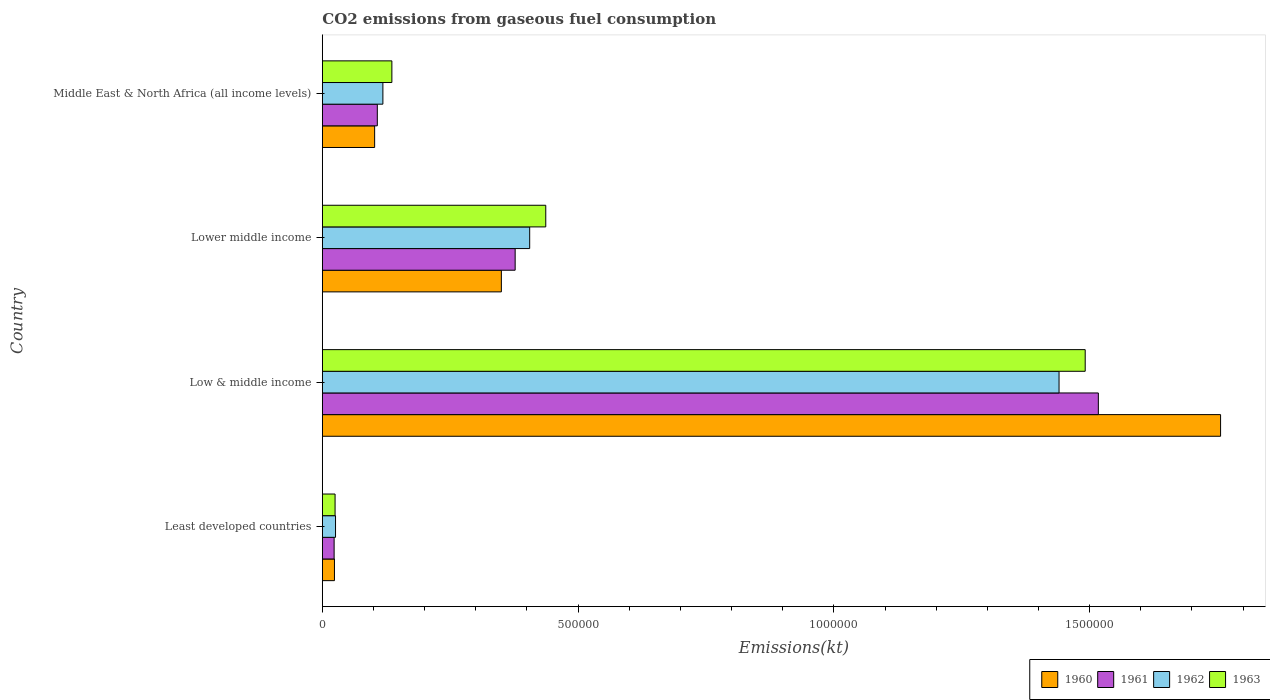How many different coloured bars are there?
Your answer should be compact. 4. How many groups of bars are there?
Your answer should be compact. 4. Are the number of bars per tick equal to the number of legend labels?
Offer a terse response. Yes. What is the label of the 4th group of bars from the top?
Keep it short and to the point. Least developed countries. What is the amount of CO2 emitted in 1961 in Lower middle income?
Ensure brevity in your answer.  3.77e+05. Across all countries, what is the maximum amount of CO2 emitted in 1960?
Keep it short and to the point. 1.76e+06. Across all countries, what is the minimum amount of CO2 emitted in 1962?
Ensure brevity in your answer.  2.58e+04. In which country was the amount of CO2 emitted in 1961 minimum?
Offer a very short reply. Least developed countries. What is the total amount of CO2 emitted in 1963 in the graph?
Your answer should be very brief. 2.09e+06. What is the difference between the amount of CO2 emitted in 1960 in Least developed countries and that in Low & middle income?
Ensure brevity in your answer.  -1.73e+06. What is the difference between the amount of CO2 emitted in 1963 in Lower middle income and the amount of CO2 emitted in 1962 in Middle East & North Africa (all income levels)?
Provide a short and direct response. 3.18e+05. What is the average amount of CO2 emitted in 1961 per country?
Make the answer very short. 5.06e+05. What is the difference between the amount of CO2 emitted in 1960 and amount of CO2 emitted in 1961 in Lower middle income?
Your answer should be very brief. -2.70e+04. In how many countries, is the amount of CO2 emitted in 1963 greater than 400000 kt?
Provide a succinct answer. 2. What is the ratio of the amount of CO2 emitted in 1960 in Least developed countries to that in Low & middle income?
Your answer should be compact. 0.01. Is the amount of CO2 emitted in 1960 in Low & middle income less than that in Lower middle income?
Your answer should be compact. No. What is the difference between the highest and the second highest amount of CO2 emitted in 1960?
Make the answer very short. 1.41e+06. What is the difference between the highest and the lowest amount of CO2 emitted in 1962?
Give a very brief answer. 1.41e+06. How many countries are there in the graph?
Your answer should be compact. 4. Are the values on the major ticks of X-axis written in scientific E-notation?
Your answer should be very brief. No. Does the graph contain any zero values?
Make the answer very short. No. Does the graph contain grids?
Offer a very short reply. No. Where does the legend appear in the graph?
Make the answer very short. Bottom right. How are the legend labels stacked?
Your answer should be very brief. Horizontal. What is the title of the graph?
Ensure brevity in your answer.  CO2 emissions from gaseous fuel consumption. Does "1997" appear as one of the legend labels in the graph?
Ensure brevity in your answer.  No. What is the label or title of the X-axis?
Provide a short and direct response. Emissions(kt). What is the Emissions(kt) of 1960 in Least developed countries?
Ensure brevity in your answer.  2.37e+04. What is the Emissions(kt) of 1961 in Least developed countries?
Give a very brief answer. 2.31e+04. What is the Emissions(kt) of 1962 in Least developed countries?
Provide a short and direct response. 2.58e+04. What is the Emissions(kt) in 1963 in Least developed countries?
Keep it short and to the point. 2.49e+04. What is the Emissions(kt) of 1960 in Low & middle income?
Offer a very short reply. 1.76e+06. What is the Emissions(kt) in 1961 in Low & middle income?
Ensure brevity in your answer.  1.52e+06. What is the Emissions(kt) of 1962 in Low & middle income?
Your answer should be compact. 1.44e+06. What is the Emissions(kt) in 1963 in Low & middle income?
Keep it short and to the point. 1.49e+06. What is the Emissions(kt) in 1960 in Lower middle income?
Your response must be concise. 3.50e+05. What is the Emissions(kt) in 1961 in Lower middle income?
Ensure brevity in your answer.  3.77e+05. What is the Emissions(kt) in 1962 in Lower middle income?
Keep it short and to the point. 4.05e+05. What is the Emissions(kt) in 1963 in Lower middle income?
Provide a succinct answer. 4.37e+05. What is the Emissions(kt) in 1960 in Middle East & North Africa (all income levels)?
Your answer should be compact. 1.02e+05. What is the Emissions(kt) of 1961 in Middle East & North Africa (all income levels)?
Ensure brevity in your answer.  1.07e+05. What is the Emissions(kt) in 1962 in Middle East & North Africa (all income levels)?
Offer a very short reply. 1.18e+05. What is the Emissions(kt) of 1963 in Middle East & North Africa (all income levels)?
Offer a terse response. 1.36e+05. Across all countries, what is the maximum Emissions(kt) of 1960?
Your answer should be compact. 1.76e+06. Across all countries, what is the maximum Emissions(kt) in 1961?
Your answer should be compact. 1.52e+06. Across all countries, what is the maximum Emissions(kt) in 1962?
Your answer should be compact. 1.44e+06. Across all countries, what is the maximum Emissions(kt) of 1963?
Give a very brief answer. 1.49e+06. Across all countries, what is the minimum Emissions(kt) in 1960?
Your response must be concise. 2.37e+04. Across all countries, what is the minimum Emissions(kt) of 1961?
Give a very brief answer. 2.31e+04. Across all countries, what is the minimum Emissions(kt) of 1962?
Your answer should be very brief. 2.58e+04. Across all countries, what is the minimum Emissions(kt) of 1963?
Make the answer very short. 2.49e+04. What is the total Emissions(kt) of 1960 in the graph?
Provide a succinct answer. 2.23e+06. What is the total Emissions(kt) of 1961 in the graph?
Provide a short and direct response. 2.02e+06. What is the total Emissions(kt) of 1962 in the graph?
Make the answer very short. 1.99e+06. What is the total Emissions(kt) in 1963 in the graph?
Provide a short and direct response. 2.09e+06. What is the difference between the Emissions(kt) of 1960 in Least developed countries and that in Low & middle income?
Your answer should be compact. -1.73e+06. What is the difference between the Emissions(kt) in 1961 in Least developed countries and that in Low & middle income?
Provide a short and direct response. -1.49e+06. What is the difference between the Emissions(kt) in 1962 in Least developed countries and that in Low & middle income?
Give a very brief answer. -1.41e+06. What is the difference between the Emissions(kt) in 1963 in Least developed countries and that in Low & middle income?
Keep it short and to the point. -1.47e+06. What is the difference between the Emissions(kt) of 1960 in Least developed countries and that in Lower middle income?
Offer a very short reply. -3.26e+05. What is the difference between the Emissions(kt) of 1961 in Least developed countries and that in Lower middle income?
Ensure brevity in your answer.  -3.54e+05. What is the difference between the Emissions(kt) in 1962 in Least developed countries and that in Lower middle income?
Offer a terse response. -3.80e+05. What is the difference between the Emissions(kt) in 1963 in Least developed countries and that in Lower middle income?
Offer a terse response. -4.12e+05. What is the difference between the Emissions(kt) of 1960 in Least developed countries and that in Middle East & North Africa (all income levels)?
Offer a terse response. -7.86e+04. What is the difference between the Emissions(kt) in 1961 in Least developed countries and that in Middle East & North Africa (all income levels)?
Your answer should be compact. -8.44e+04. What is the difference between the Emissions(kt) of 1962 in Least developed countries and that in Middle East & North Africa (all income levels)?
Offer a terse response. -9.26e+04. What is the difference between the Emissions(kt) in 1963 in Least developed countries and that in Middle East & North Africa (all income levels)?
Your answer should be compact. -1.11e+05. What is the difference between the Emissions(kt) in 1960 in Low & middle income and that in Lower middle income?
Your answer should be very brief. 1.41e+06. What is the difference between the Emissions(kt) in 1961 in Low & middle income and that in Lower middle income?
Offer a terse response. 1.14e+06. What is the difference between the Emissions(kt) of 1962 in Low & middle income and that in Lower middle income?
Your response must be concise. 1.03e+06. What is the difference between the Emissions(kt) of 1963 in Low & middle income and that in Lower middle income?
Your response must be concise. 1.05e+06. What is the difference between the Emissions(kt) of 1960 in Low & middle income and that in Middle East & North Africa (all income levels)?
Keep it short and to the point. 1.65e+06. What is the difference between the Emissions(kt) of 1961 in Low & middle income and that in Middle East & North Africa (all income levels)?
Offer a terse response. 1.41e+06. What is the difference between the Emissions(kt) of 1962 in Low & middle income and that in Middle East & North Africa (all income levels)?
Give a very brief answer. 1.32e+06. What is the difference between the Emissions(kt) in 1963 in Low & middle income and that in Middle East & North Africa (all income levels)?
Provide a short and direct response. 1.36e+06. What is the difference between the Emissions(kt) in 1960 in Lower middle income and that in Middle East & North Africa (all income levels)?
Offer a terse response. 2.48e+05. What is the difference between the Emissions(kt) of 1961 in Lower middle income and that in Middle East & North Africa (all income levels)?
Your response must be concise. 2.69e+05. What is the difference between the Emissions(kt) of 1962 in Lower middle income and that in Middle East & North Africa (all income levels)?
Ensure brevity in your answer.  2.87e+05. What is the difference between the Emissions(kt) in 1963 in Lower middle income and that in Middle East & North Africa (all income levels)?
Give a very brief answer. 3.01e+05. What is the difference between the Emissions(kt) in 1960 in Least developed countries and the Emissions(kt) in 1961 in Low & middle income?
Your answer should be compact. -1.49e+06. What is the difference between the Emissions(kt) in 1960 in Least developed countries and the Emissions(kt) in 1962 in Low & middle income?
Offer a very short reply. -1.42e+06. What is the difference between the Emissions(kt) of 1960 in Least developed countries and the Emissions(kt) of 1963 in Low & middle income?
Keep it short and to the point. -1.47e+06. What is the difference between the Emissions(kt) of 1961 in Least developed countries and the Emissions(kt) of 1962 in Low & middle income?
Offer a very short reply. -1.42e+06. What is the difference between the Emissions(kt) of 1961 in Least developed countries and the Emissions(kt) of 1963 in Low & middle income?
Make the answer very short. -1.47e+06. What is the difference between the Emissions(kt) of 1962 in Least developed countries and the Emissions(kt) of 1963 in Low & middle income?
Offer a very short reply. -1.47e+06. What is the difference between the Emissions(kt) of 1960 in Least developed countries and the Emissions(kt) of 1961 in Lower middle income?
Your answer should be very brief. -3.53e+05. What is the difference between the Emissions(kt) of 1960 in Least developed countries and the Emissions(kt) of 1962 in Lower middle income?
Your answer should be very brief. -3.82e+05. What is the difference between the Emissions(kt) in 1960 in Least developed countries and the Emissions(kt) in 1963 in Lower middle income?
Make the answer very short. -4.13e+05. What is the difference between the Emissions(kt) of 1961 in Least developed countries and the Emissions(kt) of 1962 in Lower middle income?
Your answer should be compact. -3.82e+05. What is the difference between the Emissions(kt) of 1961 in Least developed countries and the Emissions(kt) of 1963 in Lower middle income?
Keep it short and to the point. -4.14e+05. What is the difference between the Emissions(kt) in 1962 in Least developed countries and the Emissions(kt) in 1963 in Lower middle income?
Your answer should be very brief. -4.11e+05. What is the difference between the Emissions(kt) in 1960 in Least developed countries and the Emissions(kt) in 1961 in Middle East & North Africa (all income levels)?
Provide a succinct answer. -8.38e+04. What is the difference between the Emissions(kt) in 1960 in Least developed countries and the Emissions(kt) in 1962 in Middle East & North Africa (all income levels)?
Ensure brevity in your answer.  -9.47e+04. What is the difference between the Emissions(kt) of 1960 in Least developed countries and the Emissions(kt) of 1963 in Middle East & North Africa (all income levels)?
Make the answer very short. -1.12e+05. What is the difference between the Emissions(kt) of 1961 in Least developed countries and the Emissions(kt) of 1962 in Middle East & North Africa (all income levels)?
Offer a terse response. -9.53e+04. What is the difference between the Emissions(kt) in 1961 in Least developed countries and the Emissions(kt) in 1963 in Middle East & North Africa (all income levels)?
Keep it short and to the point. -1.13e+05. What is the difference between the Emissions(kt) of 1962 in Least developed countries and the Emissions(kt) of 1963 in Middle East & North Africa (all income levels)?
Your answer should be compact. -1.10e+05. What is the difference between the Emissions(kt) of 1960 in Low & middle income and the Emissions(kt) of 1961 in Lower middle income?
Provide a succinct answer. 1.38e+06. What is the difference between the Emissions(kt) of 1960 in Low & middle income and the Emissions(kt) of 1962 in Lower middle income?
Provide a succinct answer. 1.35e+06. What is the difference between the Emissions(kt) of 1960 in Low & middle income and the Emissions(kt) of 1963 in Lower middle income?
Offer a very short reply. 1.32e+06. What is the difference between the Emissions(kt) in 1961 in Low & middle income and the Emissions(kt) in 1962 in Lower middle income?
Provide a succinct answer. 1.11e+06. What is the difference between the Emissions(kt) in 1961 in Low & middle income and the Emissions(kt) in 1963 in Lower middle income?
Give a very brief answer. 1.08e+06. What is the difference between the Emissions(kt) of 1962 in Low & middle income and the Emissions(kt) of 1963 in Lower middle income?
Offer a terse response. 1.00e+06. What is the difference between the Emissions(kt) of 1960 in Low & middle income and the Emissions(kt) of 1961 in Middle East & North Africa (all income levels)?
Ensure brevity in your answer.  1.65e+06. What is the difference between the Emissions(kt) of 1960 in Low & middle income and the Emissions(kt) of 1962 in Middle East & North Africa (all income levels)?
Provide a short and direct response. 1.64e+06. What is the difference between the Emissions(kt) of 1960 in Low & middle income and the Emissions(kt) of 1963 in Middle East & North Africa (all income levels)?
Your response must be concise. 1.62e+06. What is the difference between the Emissions(kt) in 1961 in Low & middle income and the Emissions(kt) in 1962 in Middle East & North Africa (all income levels)?
Your response must be concise. 1.40e+06. What is the difference between the Emissions(kt) in 1961 in Low & middle income and the Emissions(kt) in 1963 in Middle East & North Africa (all income levels)?
Provide a succinct answer. 1.38e+06. What is the difference between the Emissions(kt) of 1962 in Low & middle income and the Emissions(kt) of 1963 in Middle East & North Africa (all income levels)?
Offer a very short reply. 1.30e+06. What is the difference between the Emissions(kt) of 1960 in Lower middle income and the Emissions(kt) of 1961 in Middle East & North Africa (all income levels)?
Keep it short and to the point. 2.42e+05. What is the difference between the Emissions(kt) in 1960 in Lower middle income and the Emissions(kt) in 1962 in Middle East & North Africa (all income levels)?
Offer a terse response. 2.32e+05. What is the difference between the Emissions(kt) in 1960 in Lower middle income and the Emissions(kt) in 1963 in Middle East & North Africa (all income levels)?
Provide a succinct answer. 2.14e+05. What is the difference between the Emissions(kt) of 1961 in Lower middle income and the Emissions(kt) of 1962 in Middle East & North Africa (all income levels)?
Offer a very short reply. 2.59e+05. What is the difference between the Emissions(kt) in 1961 in Lower middle income and the Emissions(kt) in 1963 in Middle East & North Africa (all income levels)?
Ensure brevity in your answer.  2.41e+05. What is the difference between the Emissions(kt) of 1962 in Lower middle income and the Emissions(kt) of 1963 in Middle East & North Africa (all income levels)?
Give a very brief answer. 2.69e+05. What is the average Emissions(kt) of 1960 per country?
Provide a succinct answer. 5.58e+05. What is the average Emissions(kt) in 1961 per country?
Keep it short and to the point. 5.06e+05. What is the average Emissions(kt) in 1962 per country?
Keep it short and to the point. 4.97e+05. What is the average Emissions(kt) of 1963 per country?
Your answer should be very brief. 5.22e+05. What is the difference between the Emissions(kt) of 1960 and Emissions(kt) of 1961 in Least developed countries?
Keep it short and to the point. 649.13. What is the difference between the Emissions(kt) in 1960 and Emissions(kt) in 1962 in Least developed countries?
Offer a very short reply. -2100.39. What is the difference between the Emissions(kt) of 1960 and Emissions(kt) of 1963 in Least developed countries?
Your answer should be very brief. -1221.77. What is the difference between the Emissions(kt) of 1961 and Emissions(kt) of 1962 in Least developed countries?
Your answer should be compact. -2749.52. What is the difference between the Emissions(kt) of 1961 and Emissions(kt) of 1963 in Least developed countries?
Offer a terse response. -1870.9. What is the difference between the Emissions(kt) of 1962 and Emissions(kt) of 1963 in Least developed countries?
Provide a short and direct response. 878.62. What is the difference between the Emissions(kt) of 1960 and Emissions(kt) of 1961 in Low & middle income?
Keep it short and to the point. 2.39e+05. What is the difference between the Emissions(kt) in 1960 and Emissions(kt) in 1962 in Low & middle income?
Give a very brief answer. 3.16e+05. What is the difference between the Emissions(kt) in 1960 and Emissions(kt) in 1963 in Low & middle income?
Make the answer very short. 2.65e+05. What is the difference between the Emissions(kt) of 1961 and Emissions(kt) of 1962 in Low & middle income?
Make the answer very short. 7.68e+04. What is the difference between the Emissions(kt) in 1961 and Emissions(kt) in 1963 in Low & middle income?
Your answer should be very brief. 2.57e+04. What is the difference between the Emissions(kt) of 1962 and Emissions(kt) of 1963 in Low & middle income?
Offer a very short reply. -5.11e+04. What is the difference between the Emissions(kt) of 1960 and Emissions(kt) of 1961 in Lower middle income?
Your response must be concise. -2.70e+04. What is the difference between the Emissions(kt) in 1960 and Emissions(kt) in 1962 in Lower middle income?
Offer a terse response. -5.54e+04. What is the difference between the Emissions(kt) in 1960 and Emissions(kt) in 1963 in Lower middle income?
Your answer should be compact. -8.68e+04. What is the difference between the Emissions(kt) of 1961 and Emissions(kt) of 1962 in Lower middle income?
Your answer should be very brief. -2.84e+04. What is the difference between the Emissions(kt) in 1961 and Emissions(kt) in 1963 in Lower middle income?
Provide a succinct answer. -5.98e+04. What is the difference between the Emissions(kt) of 1962 and Emissions(kt) of 1963 in Lower middle income?
Offer a very short reply. -3.14e+04. What is the difference between the Emissions(kt) in 1960 and Emissions(kt) in 1961 in Middle East & North Africa (all income levels)?
Your response must be concise. -5245.97. What is the difference between the Emissions(kt) in 1960 and Emissions(kt) in 1962 in Middle East & North Africa (all income levels)?
Provide a short and direct response. -1.61e+04. What is the difference between the Emissions(kt) in 1960 and Emissions(kt) in 1963 in Middle East & North Africa (all income levels)?
Provide a short and direct response. -3.37e+04. What is the difference between the Emissions(kt) of 1961 and Emissions(kt) of 1962 in Middle East & North Africa (all income levels)?
Keep it short and to the point. -1.09e+04. What is the difference between the Emissions(kt) of 1961 and Emissions(kt) of 1963 in Middle East & North Africa (all income levels)?
Keep it short and to the point. -2.84e+04. What is the difference between the Emissions(kt) in 1962 and Emissions(kt) in 1963 in Middle East & North Africa (all income levels)?
Your answer should be very brief. -1.75e+04. What is the ratio of the Emissions(kt) of 1960 in Least developed countries to that in Low & middle income?
Give a very brief answer. 0.01. What is the ratio of the Emissions(kt) in 1961 in Least developed countries to that in Low & middle income?
Provide a short and direct response. 0.02. What is the ratio of the Emissions(kt) of 1962 in Least developed countries to that in Low & middle income?
Offer a terse response. 0.02. What is the ratio of the Emissions(kt) of 1963 in Least developed countries to that in Low & middle income?
Provide a short and direct response. 0.02. What is the ratio of the Emissions(kt) of 1960 in Least developed countries to that in Lower middle income?
Make the answer very short. 0.07. What is the ratio of the Emissions(kt) in 1961 in Least developed countries to that in Lower middle income?
Your response must be concise. 0.06. What is the ratio of the Emissions(kt) in 1962 in Least developed countries to that in Lower middle income?
Ensure brevity in your answer.  0.06. What is the ratio of the Emissions(kt) of 1963 in Least developed countries to that in Lower middle income?
Provide a succinct answer. 0.06. What is the ratio of the Emissions(kt) in 1960 in Least developed countries to that in Middle East & North Africa (all income levels)?
Offer a very short reply. 0.23. What is the ratio of the Emissions(kt) in 1961 in Least developed countries to that in Middle East & North Africa (all income levels)?
Offer a terse response. 0.21. What is the ratio of the Emissions(kt) in 1962 in Least developed countries to that in Middle East & North Africa (all income levels)?
Provide a succinct answer. 0.22. What is the ratio of the Emissions(kt) of 1963 in Least developed countries to that in Middle East & North Africa (all income levels)?
Provide a short and direct response. 0.18. What is the ratio of the Emissions(kt) of 1960 in Low & middle income to that in Lower middle income?
Give a very brief answer. 5.02. What is the ratio of the Emissions(kt) in 1961 in Low & middle income to that in Lower middle income?
Keep it short and to the point. 4.02. What is the ratio of the Emissions(kt) of 1962 in Low & middle income to that in Lower middle income?
Your answer should be very brief. 3.55. What is the ratio of the Emissions(kt) of 1963 in Low & middle income to that in Lower middle income?
Your response must be concise. 3.41. What is the ratio of the Emissions(kt) in 1960 in Low & middle income to that in Middle East & North Africa (all income levels)?
Keep it short and to the point. 17.17. What is the ratio of the Emissions(kt) of 1961 in Low & middle income to that in Middle East & North Africa (all income levels)?
Your answer should be very brief. 14.11. What is the ratio of the Emissions(kt) in 1962 in Low & middle income to that in Middle East & North Africa (all income levels)?
Offer a terse response. 12.16. What is the ratio of the Emissions(kt) of 1963 in Low & middle income to that in Middle East & North Africa (all income levels)?
Offer a terse response. 10.97. What is the ratio of the Emissions(kt) of 1960 in Lower middle income to that in Middle East & North Africa (all income levels)?
Provide a succinct answer. 3.42. What is the ratio of the Emissions(kt) in 1961 in Lower middle income to that in Middle East & North Africa (all income levels)?
Offer a terse response. 3.51. What is the ratio of the Emissions(kt) in 1962 in Lower middle income to that in Middle East & North Africa (all income levels)?
Offer a very short reply. 3.42. What is the ratio of the Emissions(kt) of 1963 in Lower middle income to that in Middle East & North Africa (all income levels)?
Give a very brief answer. 3.21. What is the difference between the highest and the second highest Emissions(kt) of 1960?
Ensure brevity in your answer.  1.41e+06. What is the difference between the highest and the second highest Emissions(kt) of 1961?
Provide a short and direct response. 1.14e+06. What is the difference between the highest and the second highest Emissions(kt) in 1962?
Offer a very short reply. 1.03e+06. What is the difference between the highest and the second highest Emissions(kt) of 1963?
Give a very brief answer. 1.05e+06. What is the difference between the highest and the lowest Emissions(kt) in 1960?
Offer a very short reply. 1.73e+06. What is the difference between the highest and the lowest Emissions(kt) of 1961?
Provide a short and direct response. 1.49e+06. What is the difference between the highest and the lowest Emissions(kt) in 1962?
Give a very brief answer. 1.41e+06. What is the difference between the highest and the lowest Emissions(kt) in 1963?
Provide a succinct answer. 1.47e+06. 